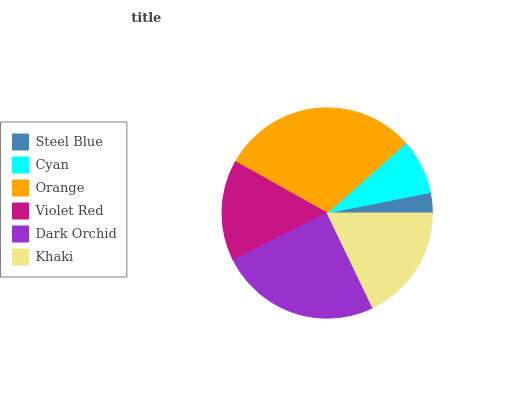Is Steel Blue the minimum?
Answer yes or no. Yes. Is Orange the maximum?
Answer yes or no. Yes. Is Cyan the minimum?
Answer yes or no. No. Is Cyan the maximum?
Answer yes or no. No. Is Cyan greater than Steel Blue?
Answer yes or no. Yes. Is Steel Blue less than Cyan?
Answer yes or no. Yes. Is Steel Blue greater than Cyan?
Answer yes or no. No. Is Cyan less than Steel Blue?
Answer yes or no. No. Is Khaki the high median?
Answer yes or no. Yes. Is Violet Red the low median?
Answer yes or no. Yes. Is Orange the high median?
Answer yes or no. No. Is Cyan the low median?
Answer yes or no. No. 